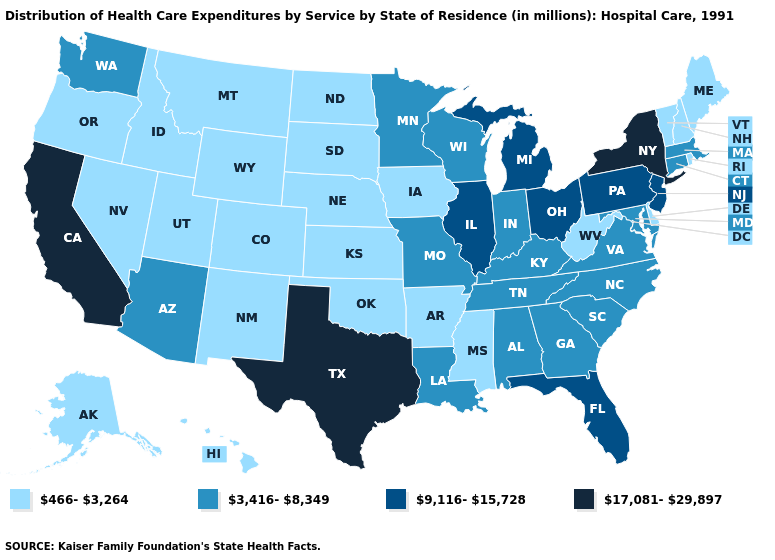Among the states that border Wyoming , which have the highest value?
Be succinct. Colorado, Idaho, Montana, Nebraska, South Dakota, Utah. Does Colorado have the lowest value in the West?
Keep it brief. Yes. What is the value of Maryland?
Quick response, please. 3,416-8,349. What is the value of Ohio?
Short answer required. 9,116-15,728. What is the lowest value in the USA?
Short answer required. 466-3,264. Name the states that have a value in the range 17,081-29,897?
Answer briefly. California, New York, Texas. What is the highest value in the USA?
Give a very brief answer. 17,081-29,897. Name the states that have a value in the range 17,081-29,897?
Keep it brief. California, New York, Texas. What is the value of Vermont?
Give a very brief answer. 466-3,264. Name the states that have a value in the range 9,116-15,728?
Give a very brief answer. Florida, Illinois, Michigan, New Jersey, Ohio, Pennsylvania. Name the states that have a value in the range 466-3,264?
Answer briefly. Alaska, Arkansas, Colorado, Delaware, Hawaii, Idaho, Iowa, Kansas, Maine, Mississippi, Montana, Nebraska, Nevada, New Hampshire, New Mexico, North Dakota, Oklahoma, Oregon, Rhode Island, South Dakota, Utah, Vermont, West Virginia, Wyoming. What is the lowest value in the South?
Short answer required. 466-3,264. What is the lowest value in the MidWest?
Keep it brief. 466-3,264. Name the states that have a value in the range 3,416-8,349?
Give a very brief answer. Alabama, Arizona, Connecticut, Georgia, Indiana, Kentucky, Louisiana, Maryland, Massachusetts, Minnesota, Missouri, North Carolina, South Carolina, Tennessee, Virginia, Washington, Wisconsin. 